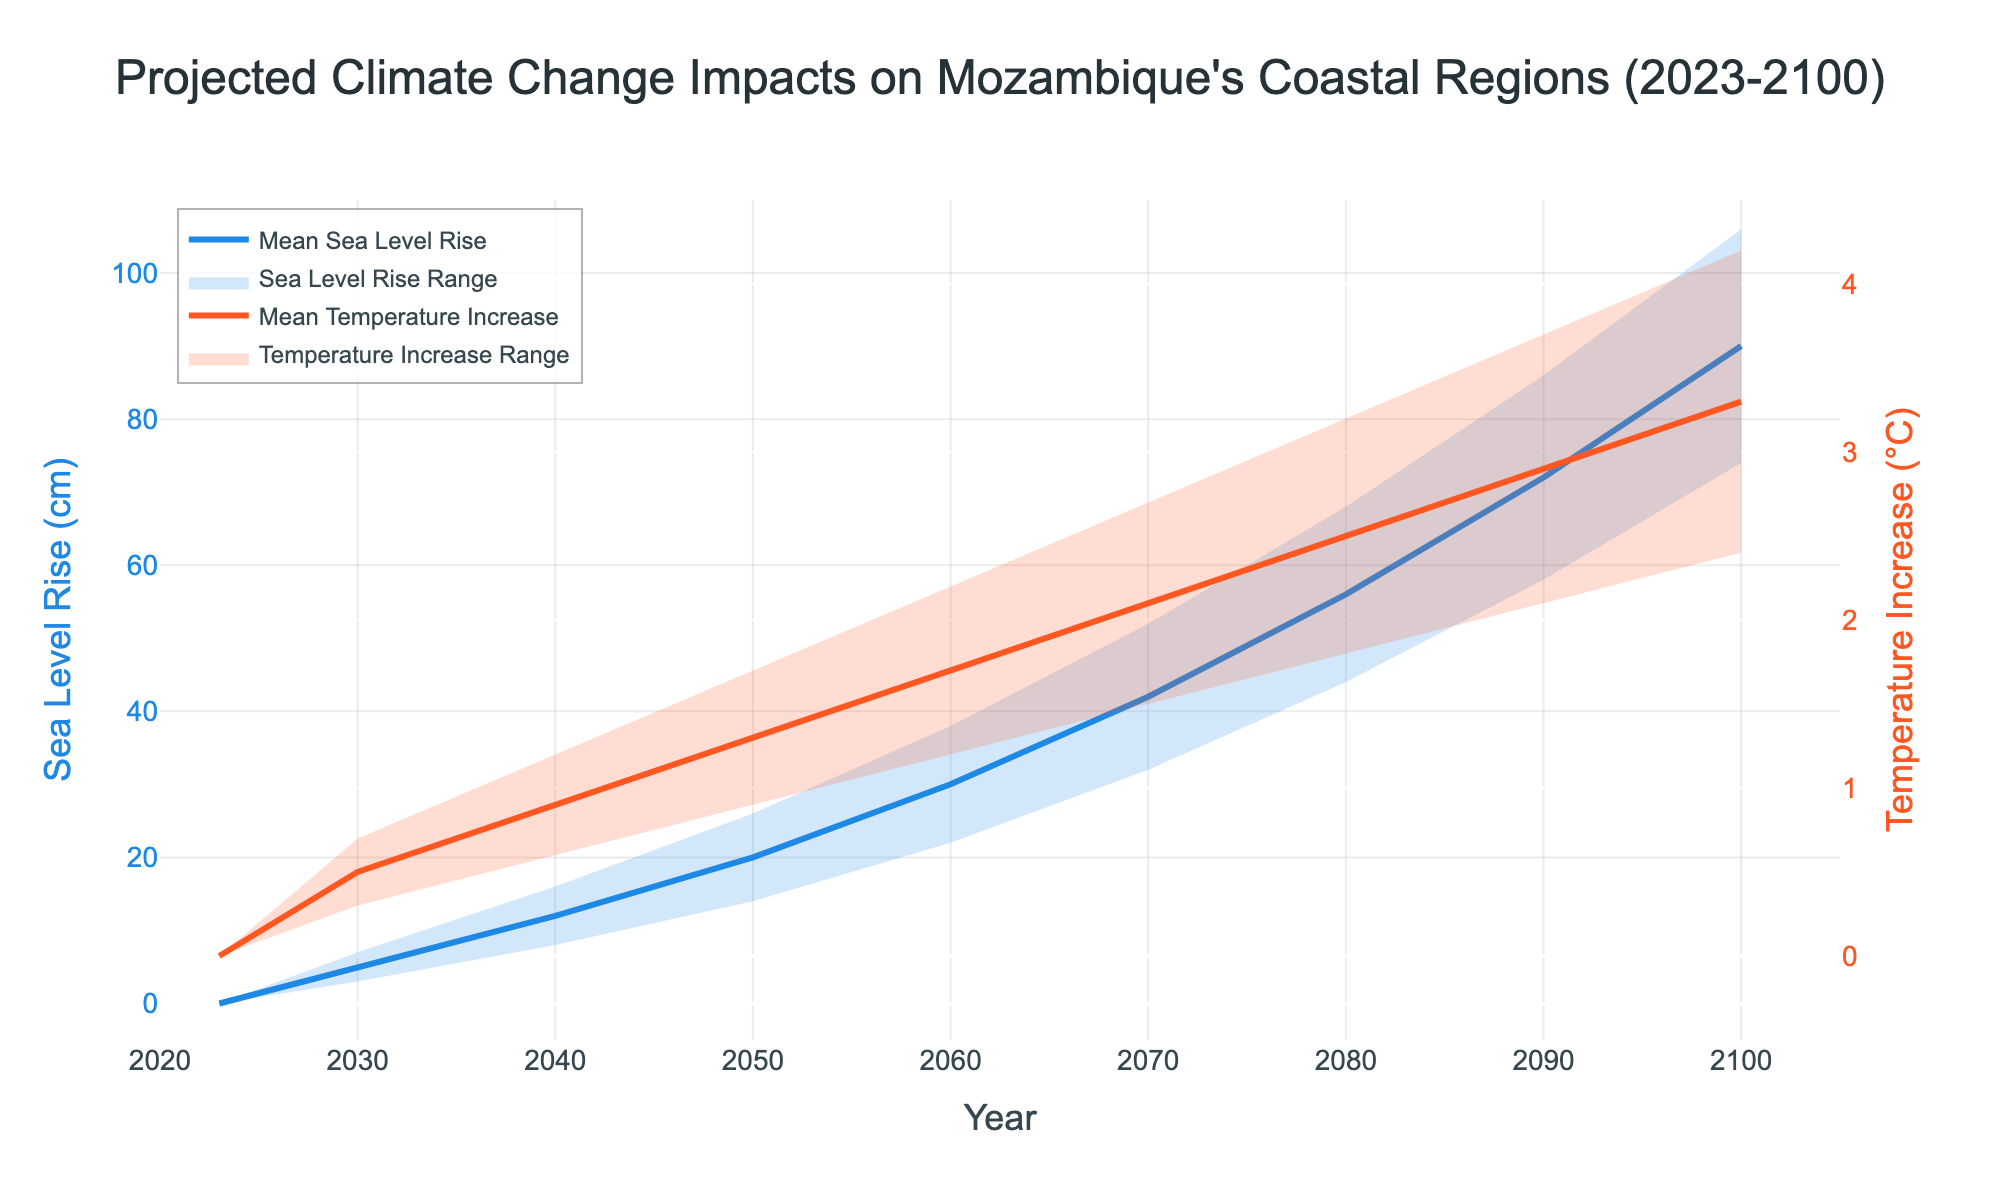What is the title of the chart? The title of the chart is found at the top center and reads as "Projected Climate Change Impacts on Mozambique's Coastal Regions (2023-2100)."
Answer: Projected Climate Change Impacts on Mozambique's Coastal Regions (2023-2100) What is the mean sea level rise in 2050? To find this, look at the 'Mean Sea Level Rise (cm)' line for the year 2050 on the chart. The chart shows it at 20 cm.
Answer: 20 cm What is the range of the sea level rise for the year 2040? For the year 2040, the chart shows the lower bound is at 8 cm and the upper bound is at 16 cm. This gives the range: 16 cm - 8 cm = 8 cm.
Answer: 8 cm By how much is the sea level rise expected to increase from 2030 to 2060 based on the mean values? The mean sea level rise in 2030 is 5 cm and in 2060 is 30 cm. The increase is computed as 30 cm - 5 cm.
Answer: 25 cm Which year shows the highest projected mean temperature increase and what is its value? The highest projected mean temperature increase is seen at the far right of the chart for the year 2100, which is 3.3°C.
Answer: 2100, 3.3°C How does the mean sea level rise compare in 2070 with that in 2090? According to the chart, the mean sea level rise in 2070 is 42 cm, and in 2090, it is 72 cm. The 2090 value is greater than the 2070 value.
Answer: 2090 is greater What is the difference in the upper bound of temperature increase between 2080 and 2100? The chart indicates the upper bound for 2080 is 3.2°C and for 2100 is 4.2°C. The difference is 4.2°C - 3.2°C.
Answer: 1°C In which decade does the mean sea level rise first exceed 50 cm? By examining the chart, the mean sea level rise exceeds 50 cm in the 2080s, specifically in the year 2080 where it is projected to be 56 cm.
Answer: 2080s What is the projected mean temperature increase in 2040? The mean temperature increase for the year 2040 can be found in the chart and is shown as 0.9°C.
Answer: 0.9°C How much will the mean sea level rise increase from 2060 to 2070, and what is its rate of change per year over this period? The chart shows the mean sea level rise at 30 cm in 2060 and 42 cm in 2070. The increase over the decade is 42 cm - 30 cm = 12 cm. Rate of change per year is 12 cm / 10 years.
Answer: 12 cm, 1.2 cm per year 